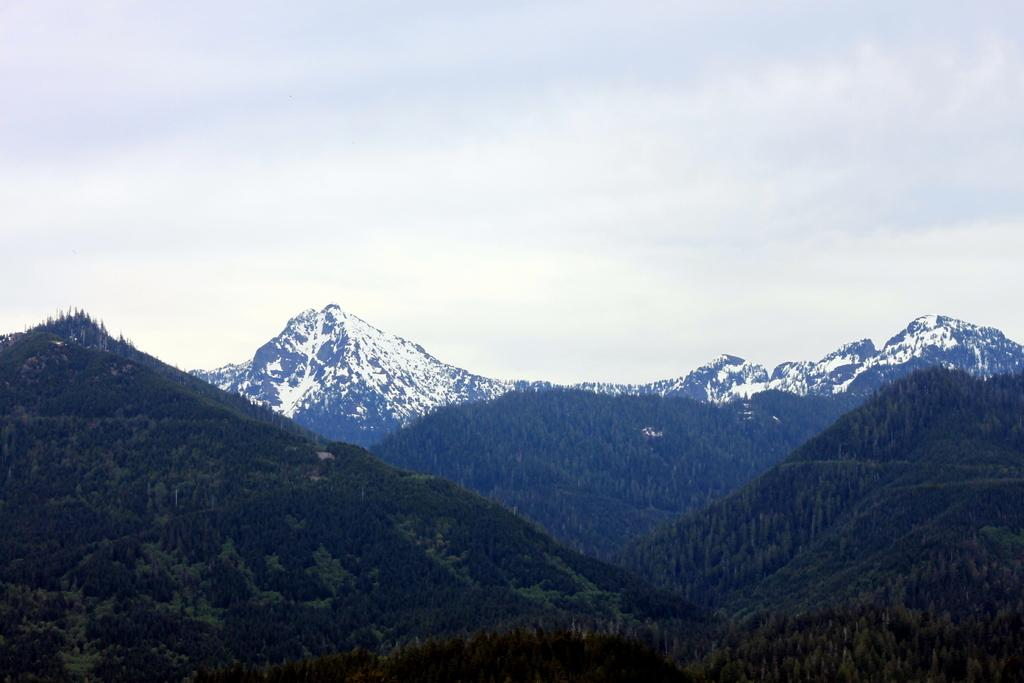What type of vegetation can be seen in the foreground of the image? There are trees in the foreground of the image. What type of vegetation can be seen in the background of the image? There are trees in the background of the image. What geographical feature is present in the image? There are mountains in the image. What is visible at the top of the image? The sky is visible at the top of the image. What type of bread can be seen growing on the trees in the image? There is no bread present in the image; it is a landscape featuring trees and mountains. What emotion is being expressed by the corn in the image? There is no corn present in the image, and therefore no emotion can be attributed to it. 